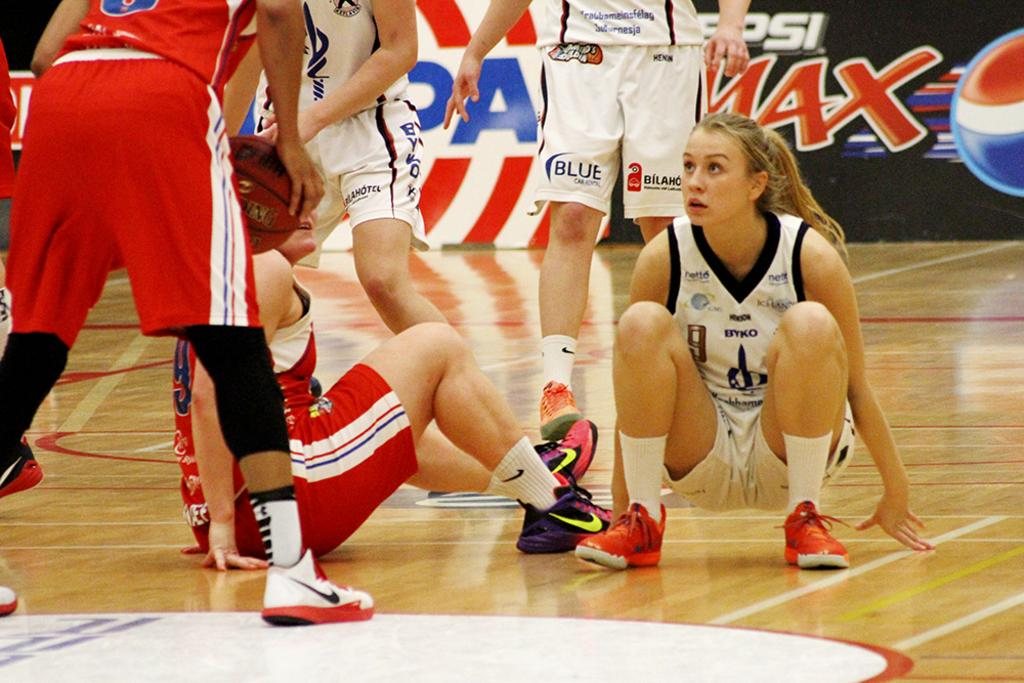<image>
Relay a brief, clear account of the picture shown. Female basketball players with one whose shorts say BLUE on it. 